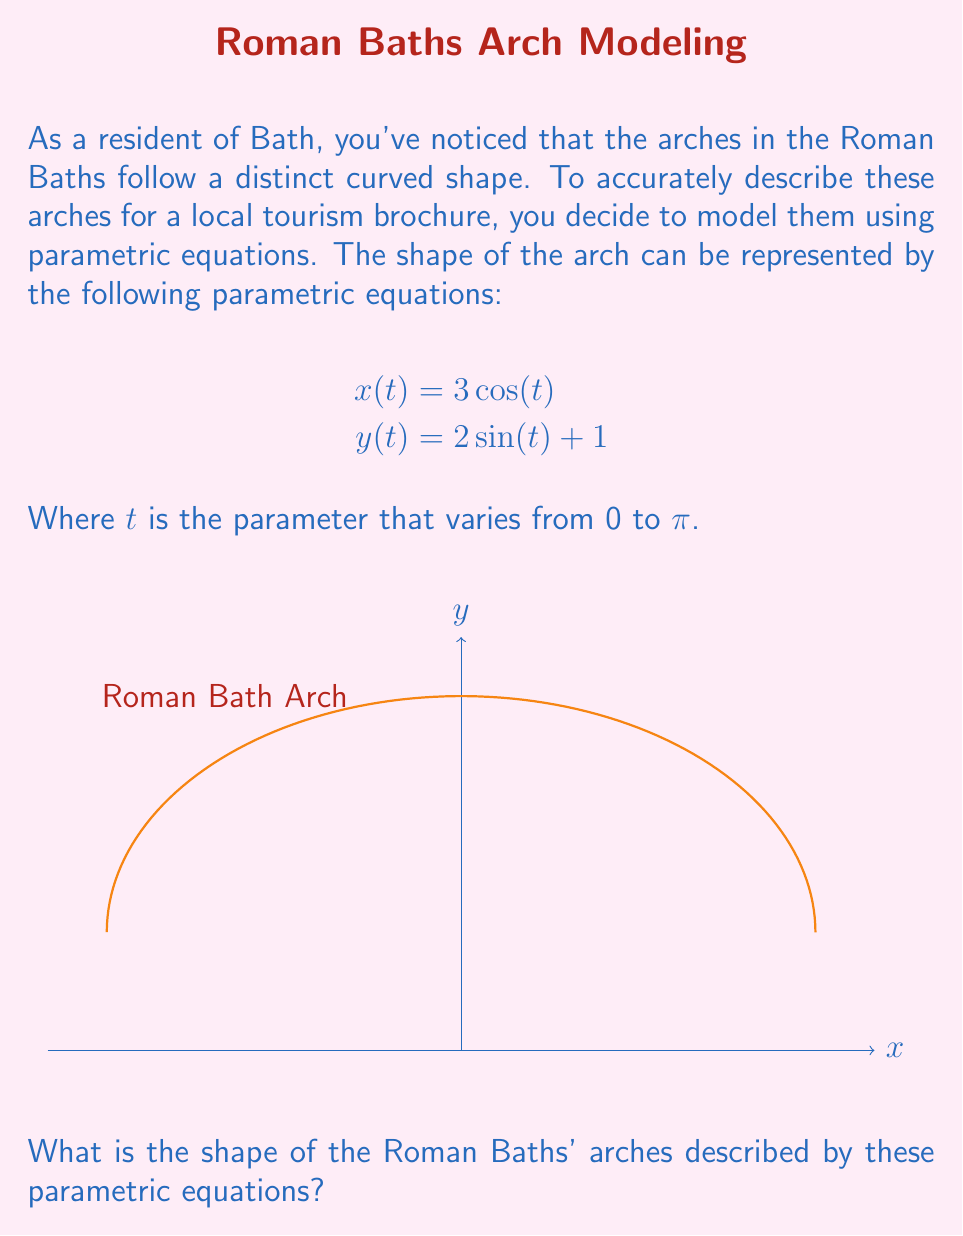What is the answer to this math problem? Let's analyze these parametric equations step-by-step:

1) First, we need to recognize the general form of these equations. They resemble the parametric form of an ellipse, but with some modifications.

2) The standard parametric equations for an ellipse centered at the origin are:
   $$x = a\cos(t)$$
   $$y = b\sin(t)$$
   where $a$ and $b$ are the semi-major and semi-minor axes.

3) In our case, we have:
   $$x = 3\cos(t)$$
   $$y = 2\sin(t) + 1$$

4) Comparing these to the standard form:
   - The x-equation matches with $a = 3$
   - The y-equation has a factor of 2 for $\sin(t)$, so $b = 2$
   - The y-equation also has a "+1" term, which indicates a vertical shift

5) This means our shape is an ellipse with:
   - Horizontal semi-axis of 3 units
   - Vertical semi-axis of 2 units
   - Centered at (0, 1) instead of (0, 0) due to the vertical shift

6) The parameter $t$ varies from 0 to $\pi$, which means we're only drawing the top half of this ellipse.

Therefore, the shape described by these parametric equations is the top half of an ellipse, which accurately represents the curved arch shape commonly found in Roman architecture.
Answer: Top half of an ellipse 